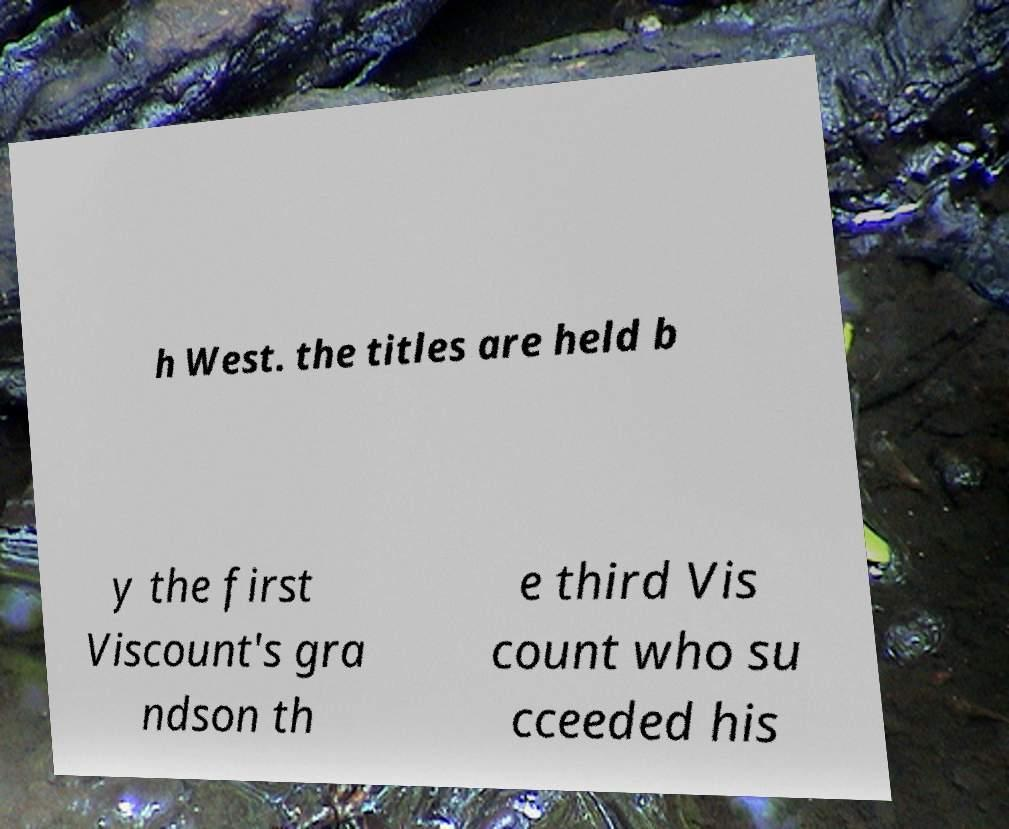For documentation purposes, I need the text within this image transcribed. Could you provide that? h West. the titles are held b y the first Viscount's gra ndson th e third Vis count who su cceeded his 